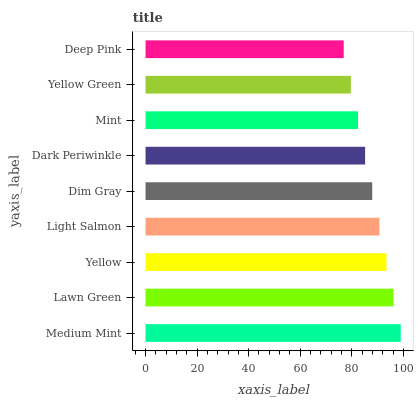Is Deep Pink the minimum?
Answer yes or no. Yes. Is Medium Mint the maximum?
Answer yes or no. Yes. Is Lawn Green the minimum?
Answer yes or no. No. Is Lawn Green the maximum?
Answer yes or no. No. Is Medium Mint greater than Lawn Green?
Answer yes or no. Yes. Is Lawn Green less than Medium Mint?
Answer yes or no. Yes. Is Lawn Green greater than Medium Mint?
Answer yes or no. No. Is Medium Mint less than Lawn Green?
Answer yes or no. No. Is Dim Gray the high median?
Answer yes or no. Yes. Is Dim Gray the low median?
Answer yes or no. Yes. Is Lawn Green the high median?
Answer yes or no. No. Is Lawn Green the low median?
Answer yes or no. No. 